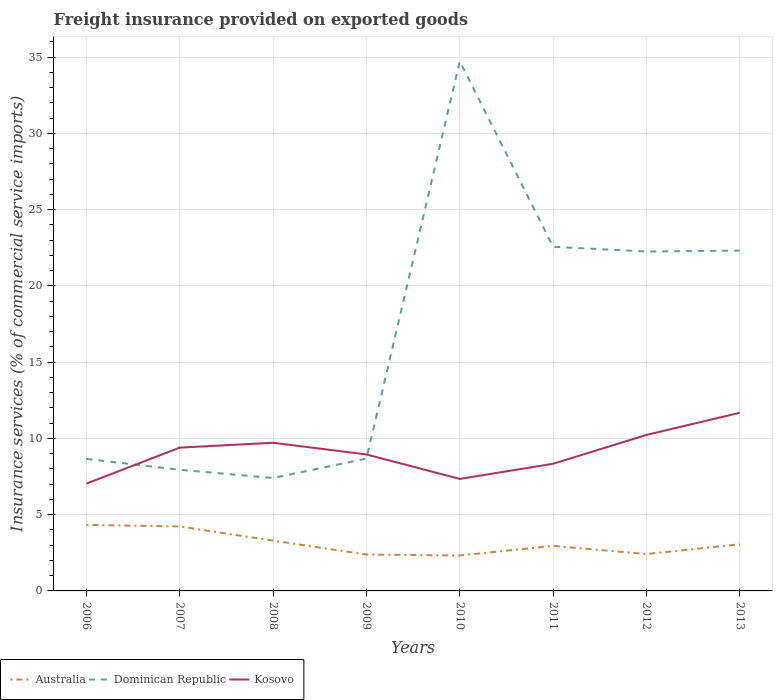How many different coloured lines are there?
Your response must be concise. 3. Does the line corresponding to Australia intersect with the line corresponding to Kosovo?
Give a very brief answer. No. Is the number of lines equal to the number of legend labels?
Give a very brief answer. Yes. Across all years, what is the maximum freight insurance provided on exported goods in Kosovo?
Your answer should be very brief. 7.04. In which year was the freight insurance provided on exported goods in Australia maximum?
Keep it short and to the point. 2010. What is the total freight insurance provided on exported goods in Kosovo in the graph?
Your response must be concise. -2.73. What is the difference between the highest and the second highest freight insurance provided on exported goods in Kosovo?
Keep it short and to the point. 4.64. Is the freight insurance provided on exported goods in Kosovo strictly greater than the freight insurance provided on exported goods in Australia over the years?
Ensure brevity in your answer.  No. How many years are there in the graph?
Your answer should be very brief. 8. Does the graph contain grids?
Offer a very short reply. Yes. Where does the legend appear in the graph?
Provide a succinct answer. Bottom left. How many legend labels are there?
Provide a succinct answer. 3. How are the legend labels stacked?
Your response must be concise. Horizontal. What is the title of the graph?
Your response must be concise. Freight insurance provided on exported goods. What is the label or title of the X-axis?
Ensure brevity in your answer.  Years. What is the label or title of the Y-axis?
Your response must be concise. Insurance services (% of commercial service imports). What is the Insurance services (% of commercial service imports) of Australia in 2006?
Your answer should be very brief. 4.33. What is the Insurance services (% of commercial service imports) in Dominican Republic in 2006?
Your response must be concise. 8.65. What is the Insurance services (% of commercial service imports) in Kosovo in 2006?
Give a very brief answer. 7.04. What is the Insurance services (% of commercial service imports) in Australia in 2007?
Make the answer very short. 4.23. What is the Insurance services (% of commercial service imports) of Dominican Republic in 2007?
Offer a very short reply. 7.94. What is the Insurance services (% of commercial service imports) of Kosovo in 2007?
Keep it short and to the point. 9.4. What is the Insurance services (% of commercial service imports) of Australia in 2008?
Your answer should be very brief. 3.3. What is the Insurance services (% of commercial service imports) in Dominican Republic in 2008?
Your response must be concise. 7.4. What is the Insurance services (% of commercial service imports) of Kosovo in 2008?
Offer a very short reply. 9.71. What is the Insurance services (% of commercial service imports) of Australia in 2009?
Offer a very short reply. 2.39. What is the Insurance services (% of commercial service imports) in Dominican Republic in 2009?
Offer a very short reply. 8.68. What is the Insurance services (% of commercial service imports) in Kosovo in 2009?
Give a very brief answer. 8.95. What is the Insurance services (% of commercial service imports) of Australia in 2010?
Give a very brief answer. 2.32. What is the Insurance services (% of commercial service imports) of Dominican Republic in 2010?
Your response must be concise. 34.73. What is the Insurance services (% of commercial service imports) of Kosovo in 2010?
Give a very brief answer. 7.34. What is the Insurance services (% of commercial service imports) of Australia in 2011?
Give a very brief answer. 2.95. What is the Insurance services (% of commercial service imports) in Dominican Republic in 2011?
Offer a very short reply. 22.56. What is the Insurance services (% of commercial service imports) of Kosovo in 2011?
Provide a short and direct response. 8.34. What is the Insurance services (% of commercial service imports) of Australia in 2012?
Give a very brief answer. 2.42. What is the Insurance services (% of commercial service imports) in Dominican Republic in 2012?
Your answer should be very brief. 22.25. What is the Insurance services (% of commercial service imports) of Kosovo in 2012?
Make the answer very short. 10.23. What is the Insurance services (% of commercial service imports) of Australia in 2013?
Offer a very short reply. 3.06. What is the Insurance services (% of commercial service imports) in Dominican Republic in 2013?
Your response must be concise. 22.31. What is the Insurance services (% of commercial service imports) of Kosovo in 2013?
Ensure brevity in your answer.  11.68. Across all years, what is the maximum Insurance services (% of commercial service imports) in Australia?
Make the answer very short. 4.33. Across all years, what is the maximum Insurance services (% of commercial service imports) of Dominican Republic?
Your answer should be compact. 34.73. Across all years, what is the maximum Insurance services (% of commercial service imports) in Kosovo?
Give a very brief answer. 11.68. Across all years, what is the minimum Insurance services (% of commercial service imports) in Australia?
Your answer should be very brief. 2.32. Across all years, what is the minimum Insurance services (% of commercial service imports) of Dominican Republic?
Give a very brief answer. 7.4. Across all years, what is the minimum Insurance services (% of commercial service imports) of Kosovo?
Give a very brief answer. 7.04. What is the total Insurance services (% of commercial service imports) of Australia in the graph?
Your response must be concise. 24.99. What is the total Insurance services (% of commercial service imports) of Dominican Republic in the graph?
Offer a very short reply. 134.54. What is the total Insurance services (% of commercial service imports) in Kosovo in the graph?
Your response must be concise. 72.69. What is the difference between the Insurance services (% of commercial service imports) in Australia in 2006 and that in 2007?
Your answer should be very brief. 0.1. What is the difference between the Insurance services (% of commercial service imports) in Dominican Republic in 2006 and that in 2007?
Offer a very short reply. 0.71. What is the difference between the Insurance services (% of commercial service imports) of Kosovo in 2006 and that in 2007?
Make the answer very short. -2.36. What is the difference between the Insurance services (% of commercial service imports) in Australia in 2006 and that in 2008?
Ensure brevity in your answer.  1.03. What is the difference between the Insurance services (% of commercial service imports) of Dominican Republic in 2006 and that in 2008?
Offer a very short reply. 1.25. What is the difference between the Insurance services (% of commercial service imports) of Kosovo in 2006 and that in 2008?
Make the answer very short. -2.68. What is the difference between the Insurance services (% of commercial service imports) of Australia in 2006 and that in 2009?
Ensure brevity in your answer.  1.94. What is the difference between the Insurance services (% of commercial service imports) of Dominican Republic in 2006 and that in 2009?
Provide a short and direct response. -0.03. What is the difference between the Insurance services (% of commercial service imports) in Kosovo in 2006 and that in 2009?
Offer a terse response. -1.91. What is the difference between the Insurance services (% of commercial service imports) of Australia in 2006 and that in 2010?
Offer a terse response. 2.01. What is the difference between the Insurance services (% of commercial service imports) of Dominican Republic in 2006 and that in 2010?
Your response must be concise. -26.07. What is the difference between the Insurance services (% of commercial service imports) of Kosovo in 2006 and that in 2010?
Provide a succinct answer. -0.31. What is the difference between the Insurance services (% of commercial service imports) of Australia in 2006 and that in 2011?
Offer a very short reply. 1.38. What is the difference between the Insurance services (% of commercial service imports) of Dominican Republic in 2006 and that in 2011?
Make the answer very short. -13.91. What is the difference between the Insurance services (% of commercial service imports) in Kosovo in 2006 and that in 2011?
Your answer should be very brief. -1.3. What is the difference between the Insurance services (% of commercial service imports) in Australia in 2006 and that in 2012?
Your answer should be very brief. 1.91. What is the difference between the Insurance services (% of commercial service imports) in Dominican Republic in 2006 and that in 2012?
Give a very brief answer. -13.6. What is the difference between the Insurance services (% of commercial service imports) of Kosovo in 2006 and that in 2012?
Your answer should be compact. -3.19. What is the difference between the Insurance services (% of commercial service imports) of Australia in 2006 and that in 2013?
Offer a terse response. 1.27. What is the difference between the Insurance services (% of commercial service imports) of Dominican Republic in 2006 and that in 2013?
Your answer should be compact. -13.66. What is the difference between the Insurance services (% of commercial service imports) in Kosovo in 2006 and that in 2013?
Keep it short and to the point. -4.64. What is the difference between the Insurance services (% of commercial service imports) in Australia in 2007 and that in 2008?
Offer a very short reply. 0.93. What is the difference between the Insurance services (% of commercial service imports) of Dominican Republic in 2007 and that in 2008?
Keep it short and to the point. 0.54. What is the difference between the Insurance services (% of commercial service imports) of Kosovo in 2007 and that in 2008?
Your answer should be very brief. -0.32. What is the difference between the Insurance services (% of commercial service imports) of Australia in 2007 and that in 2009?
Your response must be concise. 1.84. What is the difference between the Insurance services (% of commercial service imports) in Dominican Republic in 2007 and that in 2009?
Offer a very short reply. -0.74. What is the difference between the Insurance services (% of commercial service imports) in Kosovo in 2007 and that in 2009?
Make the answer very short. 0.45. What is the difference between the Insurance services (% of commercial service imports) of Australia in 2007 and that in 2010?
Offer a terse response. 1.9. What is the difference between the Insurance services (% of commercial service imports) of Dominican Republic in 2007 and that in 2010?
Keep it short and to the point. -26.79. What is the difference between the Insurance services (% of commercial service imports) in Kosovo in 2007 and that in 2010?
Ensure brevity in your answer.  2.05. What is the difference between the Insurance services (% of commercial service imports) in Australia in 2007 and that in 2011?
Your answer should be compact. 1.27. What is the difference between the Insurance services (% of commercial service imports) in Dominican Republic in 2007 and that in 2011?
Give a very brief answer. -14.62. What is the difference between the Insurance services (% of commercial service imports) in Kosovo in 2007 and that in 2011?
Provide a short and direct response. 1.06. What is the difference between the Insurance services (% of commercial service imports) of Australia in 2007 and that in 2012?
Keep it short and to the point. 1.81. What is the difference between the Insurance services (% of commercial service imports) in Dominican Republic in 2007 and that in 2012?
Offer a terse response. -14.31. What is the difference between the Insurance services (% of commercial service imports) of Kosovo in 2007 and that in 2012?
Ensure brevity in your answer.  -0.83. What is the difference between the Insurance services (% of commercial service imports) in Australia in 2007 and that in 2013?
Give a very brief answer. 1.17. What is the difference between the Insurance services (% of commercial service imports) of Dominican Republic in 2007 and that in 2013?
Provide a short and direct response. -14.37. What is the difference between the Insurance services (% of commercial service imports) in Kosovo in 2007 and that in 2013?
Give a very brief answer. -2.29. What is the difference between the Insurance services (% of commercial service imports) of Australia in 2008 and that in 2009?
Provide a short and direct response. 0.91. What is the difference between the Insurance services (% of commercial service imports) of Dominican Republic in 2008 and that in 2009?
Provide a succinct answer. -1.27. What is the difference between the Insurance services (% of commercial service imports) of Kosovo in 2008 and that in 2009?
Offer a terse response. 0.77. What is the difference between the Insurance services (% of commercial service imports) in Australia in 2008 and that in 2010?
Make the answer very short. 0.97. What is the difference between the Insurance services (% of commercial service imports) in Dominican Republic in 2008 and that in 2010?
Provide a short and direct response. -27.32. What is the difference between the Insurance services (% of commercial service imports) of Kosovo in 2008 and that in 2010?
Provide a short and direct response. 2.37. What is the difference between the Insurance services (% of commercial service imports) of Australia in 2008 and that in 2011?
Your answer should be very brief. 0.34. What is the difference between the Insurance services (% of commercial service imports) in Dominican Republic in 2008 and that in 2011?
Give a very brief answer. -15.16. What is the difference between the Insurance services (% of commercial service imports) in Kosovo in 2008 and that in 2011?
Your answer should be compact. 1.38. What is the difference between the Insurance services (% of commercial service imports) in Australia in 2008 and that in 2012?
Keep it short and to the point. 0.88. What is the difference between the Insurance services (% of commercial service imports) of Dominican Republic in 2008 and that in 2012?
Your answer should be compact. -14.85. What is the difference between the Insurance services (% of commercial service imports) of Kosovo in 2008 and that in 2012?
Keep it short and to the point. -0.51. What is the difference between the Insurance services (% of commercial service imports) of Australia in 2008 and that in 2013?
Offer a very short reply. 0.24. What is the difference between the Insurance services (% of commercial service imports) in Dominican Republic in 2008 and that in 2013?
Provide a short and direct response. -14.91. What is the difference between the Insurance services (% of commercial service imports) in Kosovo in 2008 and that in 2013?
Offer a very short reply. -1.97. What is the difference between the Insurance services (% of commercial service imports) of Australia in 2009 and that in 2010?
Make the answer very short. 0.06. What is the difference between the Insurance services (% of commercial service imports) in Dominican Republic in 2009 and that in 2010?
Your answer should be very brief. -26.05. What is the difference between the Insurance services (% of commercial service imports) of Kosovo in 2009 and that in 2010?
Make the answer very short. 1.6. What is the difference between the Insurance services (% of commercial service imports) of Australia in 2009 and that in 2011?
Ensure brevity in your answer.  -0.57. What is the difference between the Insurance services (% of commercial service imports) of Dominican Republic in 2009 and that in 2011?
Your response must be concise. -13.89. What is the difference between the Insurance services (% of commercial service imports) of Kosovo in 2009 and that in 2011?
Offer a very short reply. 0.61. What is the difference between the Insurance services (% of commercial service imports) of Australia in 2009 and that in 2012?
Keep it short and to the point. -0.03. What is the difference between the Insurance services (% of commercial service imports) in Dominican Republic in 2009 and that in 2012?
Your response must be concise. -13.57. What is the difference between the Insurance services (% of commercial service imports) in Kosovo in 2009 and that in 2012?
Keep it short and to the point. -1.28. What is the difference between the Insurance services (% of commercial service imports) in Australia in 2009 and that in 2013?
Offer a very short reply. -0.67. What is the difference between the Insurance services (% of commercial service imports) in Dominican Republic in 2009 and that in 2013?
Provide a short and direct response. -13.64. What is the difference between the Insurance services (% of commercial service imports) of Kosovo in 2009 and that in 2013?
Provide a succinct answer. -2.73. What is the difference between the Insurance services (% of commercial service imports) of Australia in 2010 and that in 2011?
Offer a terse response. -0.63. What is the difference between the Insurance services (% of commercial service imports) of Dominican Republic in 2010 and that in 2011?
Ensure brevity in your answer.  12.16. What is the difference between the Insurance services (% of commercial service imports) of Kosovo in 2010 and that in 2011?
Make the answer very short. -0.99. What is the difference between the Insurance services (% of commercial service imports) in Australia in 2010 and that in 2012?
Provide a short and direct response. -0.09. What is the difference between the Insurance services (% of commercial service imports) of Dominican Republic in 2010 and that in 2012?
Offer a very short reply. 12.47. What is the difference between the Insurance services (% of commercial service imports) in Kosovo in 2010 and that in 2012?
Offer a terse response. -2.89. What is the difference between the Insurance services (% of commercial service imports) of Australia in 2010 and that in 2013?
Make the answer very short. -0.74. What is the difference between the Insurance services (% of commercial service imports) of Dominican Republic in 2010 and that in 2013?
Your answer should be very brief. 12.41. What is the difference between the Insurance services (% of commercial service imports) in Kosovo in 2010 and that in 2013?
Ensure brevity in your answer.  -4.34. What is the difference between the Insurance services (% of commercial service imports) of Australia in 2011 and that in 2012?
Your answer should be very brief. 0.54. What is the difference between the Insurance services (% of commercial service imports) in Dominican Republic in 2011 and that in 2012?
Ensure brevity in your answer.  0.31. What is the difference between the Insurance services (% of commercial service imports) of Kosovo in 2011 and that in 2012?
Make the answer very short. -1.89. What is the difference between the Insurance services (% of commercial service imports) of Australia in 2011 and that in 2013?
Your answer should be very brief. -0.11. What is the difference between the Insurance services (% of commercial service imports) of Dominican Republic in 2011 and that in 2013?
Make the answer very short. 0.25. What is the difference between the Insurance services (% of commercial service imports) of Kosovo in 2011 and that in 2013?
Make the answer very short. -3.34. What is the difference between the Insurance services (% of commercial service imports) of Australia in 2012 and that in 2013?
Your answer should be compact. -0.64. What is the difference between the Insurance services (% of commercial service imports) in Dominican Republic in 2012 and that in 2013?
Give a very brief answer. -0.06. What is the difference between the Insurance services (% of commercial service imports) in Kosovo in 2012 and that in 2013?
Offer a terse response. -1.45. What is the difference between the Insurance services (% of commercial service imports) in Australia in 2006 and the Insurance services (% of commercial service imports) in Dominican Republic in 2007?
Keep it short and to the point. -3.61. What is the difference between the Insurance services (% of commercial service imports) of Australia in 2006 and the Insurance services (% of commercial service imports) of Kosovo in 2007?
Provide a short and direct response. -5.07. What is the difference between the Insurance services (% of commercial service imports) in Dominican Republic in 2006 and the Insurance services (% of commercial service imports) in Kosovo in 2007?
Give a very brief answer. -0.74. What is the difference between the Insurance services (% of commercial service imports) of Australia in 2006 and the Insurance services (% of commercial service imports) of Dominican Republic in 2008?
Make the answer very short. -3.08. What is the difference between the Insurance services (% of commercial service imports) in Australia in 2006 and the Insurance services (% of commercial service imports) in Kosovo in 2008?
Ensure brevity in your answer.  -5.38. What is the difference between the Insurance services (% of commercial service imports) in Dominican Republic in 2006 and the Insurance services (% of commercial service imports) in Kosovo in 2008?
Give a very brief answer. -1.06. What is the difference between the Insurance services (% of commercial service imports) of Australia in 2006 and the Insurance services (% of commercial service imports) of Dominican Republic in 2009?
Provide a succinct answer. -4.35. What is the difference between the Insurance services (% of commercial service imports) in Australia in 2006 and the Insurance services (% of commercial service imports) in Kosovo in 2009?
Your answer should be compact. -4.62. What is the difference between the Insurance services (% of commercial service imports) of Dominican Republic in 2006 and the Insurance services (% of commercial service imports) of Kosovo in 2009?
Your response must be concise. -0.29. What is the difference between the Insurance services (% of commercial service imports) of Australia in 2006 and the Insurance services (% of commercial service imports) of Dominican Republic in 2010?
Give a very brief answer. -30.4. What is the difference between the Insurance services (% of commercial service imports) in Australia in 2006 and the Insurance services (% of commercial service imports) in Kosovo in 2010?
Provide a succinct answer. -3.01. What is the difference between the Insurance services (% of commercial service imports) of Dominican Republic in 2006 and the Insurance services (% of commercial service imports) of Kosovo in 2010?
Offer a terse response. 1.31. What is the difference between the Insurance services (% of commercial service imports) of Australia in 2006 and the Insurance services (% of commercial service imports) of Dominican Republic in 2011?
Your answer should be very brief. -18.23. What is the difference between the Insurance services (% of commercial service imports) of Australia in 2006 and the Insurance services (% of commercial service imports) of Kosovo in 2011?
Provide a short and direct response. -4.01. What is the difference between the Insurance services (% of commercial service imports) in Dominican Republic in 2006 and the Insurance services (% of commercial service imports) in Kosovo in 2011?
Ensure brevity in your answer.  0.32. What is the difference between the Insurance services (% of commercial service imports) of Australia in 2006 and the Insurance services (% of commercial service imports) of Dominican Republic in 2012?
Offer a terse response. -17.92. What is the difference between the Insurance services (% of commercial service imports) of Australia in 2006 and the Insurance services (% of commercial service imports) of Kosovo in 2012?
Your answer should be compact. -5.9. What is the difference between the Insurance services (% of commercial service imports) of Dominican Republic in 2006 and the Insurance services (% of commercial service imports) of Kosovo in 2012?
Offer a terse response. -1.57. What is the difference between the Insurance services (% of commercial service imports) of Australia in 2006 and the Insurance services (% of commercial service imports) of Dominican Republic in 2013?
Your response must be concise. -17.98. What is the difference between the Insurance services (% of commercial service imports) of Australia in 2006 and the Insurance services (% of commercial service imports) of Kosovo in 2013?
Provide a short and direct response. -7.35. What is the difference between the Insurance services (% of commercial service imports) in Dominican Republic in 2006 and the Insurance services (% of commercial service imports) in Kosovo in 2013?
Your response must be concise. -3.03. What is the difference between the Insurance services (% of commercial service imports) in Australia in 2007 and the Insurance services (% of commercial service imports) in Dominican Republic in 2008?
Offer a terse response. -3.18. What is the difference between the Insurance services (% of commercial service imports) of Australia in 2007 and the Insurance services (% of commercial service imports) of Kosovo in 2008?
Provide a succinct answer. -5.49. What is the difference between the Insurance services (% of commercial service imports) of Dominican Republic in 2007 and the Insurance services (% of commercial service imports) of Kosovo in 2008?
Offer a terse response. -1.77. What is the difference between the Insurance services (% of commercial service imports) of Australia in 2007 and the Insurance services (% of commercial service imports) of Dominican Republic in 2009?
Offer a terse response. -4.45. What is the difference between the Insurance services (% of commercial service imports) of Australia in 2007 and the Insurance services (% of commercial service imports) of Kosovo in 2009?
Make the answer very short. -4.72. What is the difference between the Insurance services (% of commercial service imports) in Dominican Republic in 2007 and the Insurance services (% of commercial service imports) in Kosovo in 2009?
Keep it short and to the point. -1.01. What is the difference between the Insurance services (% of commercial service imports) in Australia in 2007 and the Insurance services (% of commercial service imports) in Dominican Republic in 2010?
Your answer should be compact. -30.5. What is the difference between the Insurance services (% of commercial service imports) in Australia in 2007 and the Insurance services (% of commercial service imports) in Kosovo in 2010?
Your response must be concise. -3.12. What is the difference between the Insurance services (% of commercial service imports) in Dominican Republic in 2007 and the Insurance services (% of commercial service imports) in Kosovo in 2010?
Offer a terse response. 0.6. What is the difference between the Insurance services (% of commercial service imports) in Australia in 2007 and the Insurance services (% of commercial service imports) in Dominican Republic in 2011?
Your response must be concise. -18.34. What is the difference between the Insurance services (% of commercial service imports) of Australia in 2007 and the Insurance services (% of commercial service imports) of Kosovo in 2011?
Provide a short and direct response. -4.11. What is the difference between the Insurance services (% of commercial service imports) in Dominican Republic in 2007 and the Insurance services (% of commercial service imports) in Kosovo in 2011?
Keep it short and to the point. -0.4. What is the difference between the Insurance services (% of commercial service imports) of Australia in 2007 and the Insurance services (% of commercial service imports) of Dominican Republic in 2012?
Make the answer very short. -18.03. What is the difference between the Insurance services (% of commercial service imports) in Australia in 2007 and the Insurance services (% of commercial service imports) in Kosovo in 2012?
Provide a short and direct response. -6. What is the difference between the Insurance services (% of commercial service imports) in Dominican Republic in 2007 and the Insurance services (% of commercial service imports) in Kosovo in 2012?
Your answer should be compact. -2.29. What is the difference between the Insurance services (% of commercial service imports) in Australia in 2007 and the Insurance services (% of commercial service imports) in Dominican Republic in 2013?
Your answer should be compact. -18.09. What is the difference between the Insurance services (% of commercial service imports) in Australia in 2007 and the Insurance services (% of commercial service imports) in Kosovo in 2013?
Your answer should be compact. -7.46. What is the difference between the Insurance services (% of commercial service imports) of Dominican Republic in 2007 and the Insurance services (% of commercial service imports) of Kosovo in 2013?
Your answer should be compact. -3.74. What is the difference between the Insurance services (% of commercial service imports) in Australia in 2008 and the Insurance services (% of commercial service imports) in Dominican Republic in 2009?
Give a very brief answer. -5.38. What is the difference between the Insurance services (% of commercial service imports) in Australia in 2008 and the Insurance services (% of commercial service imports) in Kosovo in 2009?
Offer a terse response. -5.65. What is the difference between the Insurance services (% of commercial service imports) in Dominican Republic in 2008 and the Insurance services (% of commercial service imports) in Kosovo in 2009?
Your answer should be compact. -1.54. What is the difference between the Insurance services (% of commercial service imports) of Australia in 2008 and the Insurance services (% of commercial service imports) of Dominican Republic in 2010?
Offer a very short reply. -31.43. What is the difference between the Insurance services (% of commercial service imports) of Australia in 2008 and the Insurance services (% of commercial service imports) of Kosovo in 2010?
Make the answer very short. -4.05. What is the difference between the Insurance services (% of commercial service imports) in Dominican Republic in 2008 and the Insurance services (% of commercial service imports) in Kosovo in 2010?
Make the answer very short. 0.06. What is the difference between the Insurance services (% of commercial service imports) of Australia in 2008 and the Insurance services (% of commercial service imports) of Dominican Republic in 2011?
Offer a very short reply. -19.27. What is the difference between the Insurance services (% of commercial service imports) in Australia in 2008 and the Insurance services (% of commercial service imports) in Kosovo in 2011?
Provide a short and direct response. -5.04. What is the difference between the Insurance services (% of commercial service imports) of Dominican Republic in 2008 and the Insurance services (% of commercial service imports) of Kosovo in 2011?
Provide a short and direct response. -0.93. What is the difference between the Insurance services (% of commercial service imports) in Australia in 2008 and the Insurance services (% of commercial service imports) in Dominican Republic in 2012?
Offer a very short reply. -18.96. What is the difference between the Insurance services (% of commercial service imports) in Australia in 2008 and the Insurance services (% of commercial service imports) in Kosovo in 2012?
Offer a terse response. -6.93. What is the difference between the Insurance services (% of commercial service imports) of Dominican Republic in 2008 and the Insurance services (% of commercial service imports) of Kosovo in 2012?
Provide a short and direct response. -2.82. What is the difference between the Insurance services (% of commercial service imports) in Australia in 2008 and the Insurance services (% of commercial service imports) in Dominican Republic in 2013?
Make the answer very short. -19.02. What is the difference between the Insurance services (% of commercial service imports) in Australia in 2008 and the Insurance services (% of commercial service imports) in Kosovo in 2013?
Make the answer very short. -8.38. What is the difference between the Insurance services (% of commercial service imports) of Dominican Republic in 2008 and the Insurance services (% of commercial service imports) of Kosovo in 2013?
Offer a very short reply. -4.28. What is the difference between the Insurance services (% of commercial service imports) in Australia in 2009 and the Insurance services (% of commercial service imports) in Dominican Republic in 2010?
Ensure brevity in your answer.  -32.34. What is the difference between the Insurance services (% of commercial service imports) in Australia in 2009 and the Insurance services (% of commercial service imports) in Kosovo in 2010?
Provide a short and direct response. -4.96. What is the difference between the Insurance services (% of commercial service imports) in Dominican Republic in 2009 and the Insurance services (% of commercial service imports) in Kosovo in 2010?
Your answer should be compact. 1.34. What is the difference between the Insurance services (% of commercial service imports) of Australia in 2009 and the Insurance services (% of commercial service imports) of Dominican Republic in 2011?
Provide a succinct answer. -20.18. What is the difference between the Insurance services (% of commercial service imports) in Australia in 2009 and the Insurance services (% of commercial service imports) in Kosovo in 2011?
Your response must be concise. -5.95. What is the difference between the Insurance services (% of commercial service imports) in Dominican Republic in 2009 and the Insurance services (% of commercial service imports) in Kosovo in 2011?
Your answer should be compact. 0.34. What is the difference between the Insurance services (% of commercial service imports) of Australia in 2009 and the Insurance services (% of commercial service imports) of Dominican Republic in 2012?
Offer a terse response. -19.87. What is the difference between the Insurance services (% of commercial service imports) in Australia in 2009 and the Insurance services (% of commercial service imports) in Kosovo in 2012?
Give a very brief answer. -7.84. What is the difference between the Insurance services (% of commercial service imports) in Dominican Republic in 2009 and the Insurance services (% of commercial service imports) in Kosovo in 2012?
Your answer should be compact. -1.55. What is the difference between the Insurance services (% of commercial service imports) of Australia in 2009 and the Insurance services (% of commercial service imports) of Dominican Republic in 2013?
Make the answer very short. -19.93. What is the difference between the Insurance services (% of commercial service imports) in Australia in 2009 and the Insurance services (% of commercial service imports) in Kosovo in 2013?
Your response must be concise. -9.3. What is the difference between the Insurance services (% of commercial service imports) in Dominican Republic in 2009 and the Insurance services (% of commercial service imports) in Kosovo in 2013?
Offer a terse response. -3. What is the difference between the Insurance services (% of commercial service imports) of Australia in 2010 and the Insurance services (% of commercial service imports) of Dominican Republic in 2011?
Give a very brief answer. -20.24. What is the difference between the Insurance services (% of commercial service imports) in Australia in 2010 and the Insurance services (% of commercial service imports) in Kosovo in 2011?
Offer a very short reply. -6.02. What is the difference between the Insurance services (% of commercial service imports) of Dominican Republic in 2010 and the Insurance services (% of commercial service imports) of Kosovo in 2011?
Your answer should be very brief. 26.39. What is the difference between the Insurance services (% of commercial service imports) in Australia in 2010 and the Insurance services (% of commercial service imports) in Dominican Republic in 2012?
Give a very brief answer. -19.93. What is the difference between the Insurance services (% of commercial service imports) of Australia in 2010 and the Insurance services (% of commercial service imports) of Kosovo in 2012?
Your response must be concise. -7.91. What is the difference between the Insurance services (% of commercial service imports) of Dominican Republic in 2010 and the Insurance services (% of commercial service imports) of Kosovo in 2012?
Your answer should be very brief. 24.5. What is the difference between the Insurance services (% of commercial service imports) of Australia in 2010 and the Insurance services (% of commercial service imports) of Dominican Republic in 2013?
Provide a succinct answer. -19.99. What is the difference between the Insurance services (% of commercial service imports) in Australia in 2010 and the Insurance services (% of commercial service imports) in Kosovo in 2013?
Keep it short and to the point. -9.36. What is the difference between the Insurance services (% of commercial service imports) in Dominican Republic in 2010 and the Insurance services (% of commercial service imports) in Kosovo in 2013?
Provide a succinct answer. 23.05. What is the difference between the Insurance services (% of commercial service imports) of Australia in 2011 and the Insurance services (% of commercial service imports) of Dominican Republic in 2012?
Provide a succinct answer. -19.3. What is the difference between the Insurance services (% of commercial service imports) in Australia in 2011 and the Insurance services (% of commercial service imports) in Kosovo in 2012?
Offer a terse response. -7.27. What is the difference between the Insurance services (% of commercial service imports) in Dominican Republic in 2011 and the Insurance services (% of commercial service imports) in Kosovo in 2012?
Offer a terse response. 12.34. What is the difference between the Insurance services (% of commercial service imports) in Australia in 2011 and the Insurance services (% of commercial service imports) in Dominican Republic in 2013?
Give a very brief answer. -19.36. What is the difference between the Insurance services (% of commercial service imports) in Australia in 2011 and the Insurance services (% of commercial service imports) in Kosovo in 2013?
Your answer should be very brief. -8.73. What is the difference between the Insurance services (% of commercial service imports) of Dominican Republic in 2011 and the Insurance services (% of commercial service imports) of Kosovo in 2013?
Give a very brief answer. 10.88. What is the difference between the Insurance services (% of commercial service imports) in Australia in 2012 and the Insurance services (% of commercial service imports) in Dominican Republic in 2013?
Give a very brief answer. -19.9. What is the difference between the Insurance services (% of commercial service imports) in Australia in 2012 and the Insurance services (% of commercial service imports) in Kosovo in 2013?
Your answer should be compact. -9.26. What is the difference between the Insurance services (% of commercial service imports) of Dominican Republic in 2012 and the Insurance services (% of commercial service imports) of Kosovo in 2013?
Your response must be concise. 10.57. What is the average Insurance services (% of commercial service imports) of Australia per year?
Keep it short and to the point. 3.12. What is the average Insurance services (% of commercial service imports) of Dominican Republic per year?
Provide a short and direct response. 16.82. What is the average Insurance services (% of commercial service imports) of Kosovo per year?
Provide a succinct answer. 9.09. In the year 2006, what is the difference between the Insurance services (% of commercial service imports) of Australia and Insurance services (% of commercial service imports) of Dominican Republic?
Keep it short and to the point. -4.32. In the year 2006, what is the difference between the Insurance services (% of commercial service imports) in Australia and Insurance services (% of commercial service imports) in Kosovo?
Ensure brevity in your answer.  -2.71. In the year 2006, what is the difference between the Insurance services (% of commercial service imports) of Dominican Republic and Insurance services (% of commercial service imports) of Kosovo?
Give a very brief answer. 1.62. In the year 2007, what is the difference between the Insurance services (% of commercial service imports) of Australia and Insurance services (% of commercial service imports) of Dominican Republic?
Offer a very short reply. -3.71. In the year 2007, what is the difference between the Insurance services (% of commercial service imports) of Australia and Insurance services (% of commercial service imports) of Kosovo?
Ensure brevity in your answer.  -5.17. In the year 2007, what is the difference between the Insurance services (% of commercial service imports) in Dominican Republic and Insurance services (% of commercial service imports) in Kosovo?
Provide a short and direct response. -1.46. In the year 2008, what is the difference between the Insurance services (% of commercial service imports) of Australia and Insurance services (% of commercial service imports) of Dominican Republic?
Offer a terse response. -4.11. In the year 2008, what is the difference between the Insurance services (% of commercial service imports) of Australia and Insurance services (% of commercial service imports) of Kosovo?
Make the answer very short. -6.42. In the year 2008, what is the difference between the Insurance services (% of commercial service imports) of Dominican Republic and Insurance services (% of commercial service imports) of Kosovo?
Your answer should be compact. -2.31. In the year 2009, what is the difference between the Insurance services (% of commercial service imports) of Australia and Insurance services (% of commercial service imports) of Dominican Republic?
Ensure brevity in your answer.  -6.29. In the year 2009, what is the difference between the Insurance services (% of commercial service imports) of Australia and Insurance services (% of commercial service imports) of Kosovo?
Keep it short and to the point. -6.56. In the year 2009, what is the difference between the Insurance services (% of commercial service imports) in Dominican Republic and Insurance services (% of commercial service imports) in Kosovo?
Your answer should be very brief. -0.27. In the year 2010, what is the difference between the Insurance services (% of commercial service imports) in Australia and Insurance services (% of commercial service imports) in Dominican Republic?
Make the answer very short. -32.4. In the year 2010, what is the difference between the Insurance services (% of commercial service imports) of Australia and Insurance services (% of commercial service imports) of Kosovo?
Ensure brevity in your answer.  -5.02. In the year 2010, what is the difference between the Insurance services (% of commercial service imports) in Dominican Republic and Insurance services (% of commercial service imports) in Kosovo?
Your answer should be compact. 27.38. In the year 2011, what is the difference between the Insurance services (% of commercial service imports) in Australia and Insurance services (% of commercial service imports) in Dominican Republic?
Offer a terse response. -19.61. In the year 2011, what is the difference between the Insurance services (% of commercial service imports) of Australia and Insurance services (% of commercial service imports) of Kosovo?
Your answer should be compact. -5.38. In the year 2011, what is the difference between the Insurance services (% of commercial service imports) of Dominican Republic and Insurance services (% of commercial service imports) of Kosovo?
Keep it short and to the point. 14.23. In the year 2012, what is the difference between the Insurance services (% of commercial service imports) of Australia and Insurance services (% of commercial service imports) of Dominican Republic?
Offer a terse response. -19.84. In the year 2012, what is the difference between the Insurance services (% of commercial service imports) in Australia and Insurance services (% of commercial service imports) in Kosovo?
Ensure brevity in your answer.  -7.81. In the year 2012, what is the difference between the Insurance services (% of commercial service imports) in Dominican Republic and Insurance services (% of commercial service imports) in Kosovo?
Provide a succinct answer. 12.02. In the year 2013, what is the difference between the Insurance services (% of commercial service imports) in Australia and Insurance services (% of commercial service imports) in Dominican Republic?
Provide a succinct answer. -19.25. In the year 2013, what is the difference between the Insurance services (% of commercial service imports) in Australia and Insurance services (% of commercial service imports) in Kosovo?
Offer a very short reply. -8.62. In the year 2013, what is the difference between the Insurance services (% of commercial service imports) in Dominican Republic and Insurance services (% of commercial service imports) in Kosovo?
Make the answer very short. 10.63. What is the ratio of the Insurance services (% of commercial service imports) in Australia in 2006 to that in 2007?
Offer a very short reply. 1.02. What is the ratio of the Insurance services (% of commercial service imports) in Dominican Republic in 2006 to that in 2007?
Your answer should be compact. 1.09. What is the ratio of the Insurance services (% of commercial service imports) of Kosovo in 2006 to that in 2007?
Your answer should be compact. 0.75. What is the ratio of the Insurance services (% of commercial service imports) of Australia in 2006 to that in 2008?
Your response must be concise. 1.31. What is the ratio of the Insurance services (% of commercial service imports) in Dominican Republic in 2006 to that in 2008?
Provide a short and direct response. 1.17. What is the ratio of the Insurance services (% of commercial service imports) of Kosovo in 2006 to that in 2008?
Your answer should be compact. 0.72. What is the ratio of the Insurance services (% of commercial service imports) of Australia in 2006 to that in 2009?
Offer a very short reply. 1.81. What is the ratio of the Insurance services (% of commercial service imports) of Kosovo in 2006 to that in 2009?
Your response must be concise. 0.79. What is the ratio of the Insurance services (% of commercial service imports) of Australia in 2006 to that in 2010?
Your response must be concise. 1.86. What is the ratio of the Insurance services (% of commercial service imports) of Dominican Republic in 2006 to that in 2010?
Keep it short and to the point. 0.25. What is the ratio of the Insurance services (% of commercial service imports) of Kosovo in 2006 to that in 2010?
Provide a succinct answer. 0.96. What is the ratio of the Insurance services (% of commercial service imports) of Australia in 2006 to that in 2011?
Offer a very short reply. 1.47. What is the ratio of the Insurance services (% of commercial service imports) of Dominican Republic in 2006 to that in 2011?
Your response must be concise. 0.38. What is the ratio of the Insurance services (% of commercial service imports) of Kosovo in 2006 to that in 2011?
Provide a succinct answer. 0.84. What is the ratio of the Insurance services (% of commercial service imports) of Australia in 2006 to that in 2012?
Your answer should be very brief. 1.79. What is the ratio of the Insurance services (% of commercial service imports) in Dominican Republic in 2006 to that in 2012?
Your response must be concise. 0.39. What is the ratio of the Insurance services (% of commercial service imports) of Kosovo in 2006 to that in 2012?
Offer a very short reply. 0.69. What is the ratio of the Insurance services (% of commercial service imports) of Australia in 2006 to that in 2013?
Give a very brief answer. 1.41. What is the ratio of the Insurance services (% of commercial service imports) of Dominican Republic in 2006 to that in 2013?
Your answer should be compact. 0.39. What is the ratio of the Insurance services (% of commercial service imports) of Kosovo in 2006 to that in 2013?
Give a very brief answer. 0.6. What is the ratio of the Insurance services (% of commercial service imports) in Australia in 2007 to that in 2008?
Your answer should be compact. 1.28. What is the ratio of the Insurance services (% of commercial service imports) in Dominican Republic in 2007 to that in 2008?
Provide a short and direct response. 1.07. What is the ratio of the Insurance services (% of commercial service imports) of Kosovo in 2007 to that in 2008?
Your answer should be very brief. 0.97. What is the ratio of the Insurance services (% of commercial service imports) of Australia in 2007 to that in 2009?
Your answer should be compact. 1.77. What is the ratio of the Insurance services (% of commercial service imports) of Dominican Republic in 2007 to that in 2009?
Provide a short and direct response. 0.91. What is the ratio of the Insurance services (% of commercial service imports) in Australia in 2007 to that in 2010?
Your answer should be compact. 1.82. What is the ratio of the Insurance services (% of commercial service imports) in Dominican Republic in 2007 to that in 2010?
Offer a terse response. 0.23. What is the ratio of the Insurance services (% of commercial service imports) of Kosovo in 2007 to that in 2010?
Provide a short and direct response. 1.28. What is the ratio of the Insurance services (% of commercial service imports) of Australia in 2007 to that in 2011?
Make the answer very short. 1.43. What is the ratio of the Insurance services (% of commercial service imports) in Dominican Republic in 2007 to that in 2011?
Provide a succinct answer. 0.35. What is the ratio of the Insurance services (% of commercial service imports) in Kosovo in 2007 to that in 2011?
Provide a short and direct response. 1.13. What is the ratio of the Insurance services (% of commercial service imports) in Australia in 2007 to that in 2012?
Your answer should be very brief. 1.75. What is the ratio of the Insurance services (% of commercial service imports) of Dominican Republic in 2007 to that in 2012?
Your answer should be very brief. 0.36. What is the ratio of the Insurance services (% of commercial service imports) in Kosovo in 2007 to that in 2012?
Offer a terse response. 0.92. What is the ratio of the Insurance services (% of commercial service imports) in Australia in 2007 to that in 2013?
Your answer should be compact. 1.38. What is the ratio of the Insurance services (% of commercial service imports) in Dominican Republic in 2007 to that in 2013?
Make the answer very short. 0.36. What is the ratio of the Insurance services (% of commercial service imports) in Kosovo in 2007 to that in 2013?
Ensure brevity in your answer.  0.8. What is the ratio of the Insurance services (% of commercial service imports) in Australia in 2008 to that in 2009?
Offer a terse response. 1.38. What is the ratio of the Insurance services (% of commercial service imports) in Dominican Republic in 2008 to that in 2009?
Keep it short and to the point. 0.85. What is the ratio of the Insurance services (% of commercial service imports) of Kosovo in 2008 to that in 2009?
Make the answer very short. 1.09. What is the ratio of the Insurance services (% of commercial service imports) of Australia in 2008 to that in 2010?
Offer a terse response. 1.42. What is the ratio of the Insurance services (% of commercial service imports) in Dominican Republic in 2008 to that in 2010?
Make the answer very short. 0.21. What is the ratio of the Insurance services (% of commercial service imports) of Kosovo in 2008 to that in 2010?
Make the answer very short. 1.32. What is the ratio of the Insurance services (% of commercial service imports) in Australia in 2008 to that in 2011?
Your answer should be compact. 1.12. What is the ratio of the Insurance services (% of commercial service imports) in Dominican Republic in 2008 to that in 2011?
Provide a succinct answer. 0.33. What is the ratio of the Insurance services (% of commercial service imports) in Kosovo in 2008 to that in 2011?
Provide a short and direct response. 1.17. What is the ratio of the Insurance services (% of commercial service imports) of Australia in 2008 to that in 2012?
Provide a short and direct response. 1.36. What is the ratio of the Insurance services (% of commercial service imports) in Dominican Republic in 2008 to that in 2012?
Keep it short and to the point. 0.33. What is the ratio of the Insurance services (% of commercial service imports) of Kosovo in 2008 to that in 2012?
Keep it short and to the point. 0.95. What is the ratio of the Insurance services (% of commercial service imports) of Australia in 2008 to that in 2013?
Your answer should be very brief. 1.08. What is the ratio of the Insurance services (% of commercial service imports) in Dominican Republic in 2008 to that in 2013?
Offer a terse response. 0.33. What is the ratio of the Insurance services (% of commercial service imports) of Kosovo in 2008 to that in 2013?
Offer a very short reply. 0.83. What is the ratio of the Insurance services (% of commercial service imports) of Dominican Republic in 2009 to that in 2010?
Your response must be concise. 0.25. What is the ratio of the Insurance services (% of commercial service imports) of Kosovo in 2009 to that in 2010?
Make the answer very short. 1.22. What is the ratio of the Insurance services (% of commercial service imports) in Australia in 2009 to that in 2011?
Your answer should be compact. 0.81. What is the ratio of the Insurance services (% of commercial service imports) of Dominican Republic in 2009 to that in 2011?
Your response must be concise. 0.38. What is the ratio of the Insurance services (% of commercial service imports) of Kosovo in 2009 to that in 2011?
Ensure brevity in your answer.  1.07. What is the ratio of the Insurance services (% of commercial service imports) of Australia in 2009 to that in 2012?
Your answer should be very brief. 0.99. What is the ratio of the Insurance services (% of commercial service imports) in Dominican Republic in 2009 to that in 2012?
Provide a short and direct response. 0.39. What is the ratio of the Insurance services (% of commercial service imports) of Kosovo in 2009 to that in 2012?
Your answer should be very brief. 0.87. What is the ratio of the Insurance services (% of commercial service imports) of Australia in 2009 to that in 2013?
Provide a short and direct response. 0.78. What is the ratio of the Insurance services (% of commercial service imports) of Dominican Republic in 2009 to that in 2013?
Ensure brevity in your answer.  0.39. What is the ratio of the Insurance services (% of commercial service imports) of Kosovo in 2009 to that in 2013?
Offer a terse response. 0.77. What is the ratio of the Insurance services (% of commercial service imports) in Australia in 2010 to that in 2011?
Ensure brevity in your answer.  0.79. What is the ratio of the Insurance services (% of commercial service imports) of Dominican Republic in 2010 to that in 2011?
Ensure brevity in your answer.  1.54. What is the ratio of the Insurance services (% of commercial service imports) of Kosovo in 2010 to that in 2011?
Provide a succinct answer. 0.88. What is the ratio of the Insurance services (% of commercial service imports) in Australia in 2010 to that in 2012?
Provide a short and direct response. 0.96. What is the ratio of the Insurance services (% of commercial service imports) in Dominican Republic in 2010 to that in 2012?
Ensure brevity in your answer.  1.56. What is the ratio of the Insurance services (% of commercial service imports) in Kosovo in 2010 to that in 2012?
Provide a short and direct response. 0.72. What is the ratio of the Insurance services (% of commercial service imports) in Australia in 2010 to that in 2013?
Offer a terse response. 0.76. What is the ratio of the Insurance services (% of commercial service imports) of Dominican Republic in 2010 to that in 2013?
Ensure brevity in your answer.  1.56. What is the ratio of the Insurance services (% of commercial service imports) of Kosovo in 2010 to that in 2013?
Keep it short and to the point. 0.63. What is the ratio of the Insurance services (% of commercial service imports) in Australia in 2011 to that in 2012?
Make the answer very short. 1.22. What is the ratio of the Insurance services (% of commercial service imports) of Kosovo in 2011 to that in 2012?
Ensure brevity in your answer.  0.82. What is the ratio of the Insurance services (% of commercial service imports) in Australia in 2011 to that in 2013?
Your answer should be very brief. 0.97. What is the ratio of the Insurance services (% of commercial service imports) in Dominican Republic in 2011 to that in 2013?
Provide a short and direct response. 1.01. What is the ratio of the Insurance services (% of commercial service imports) of Kosovo in 2011 to that in 2013?
Keep it short and to the point. 0.71. What is the ratio of the Insurance services (% of commercial service imports) of Australia in 2012 to that in 2013?
Offer a terse response. 0.79. What is the ratio of the Insurance services (% of commercial service imports) in Kosovo in 2012 to that in 2013?
Provide a short and direct response. 0.88. What is the difference between the highest and the second highest Insurance services (% of commercial service imports) of Australia?
Provide a succinct answer. 0.1. What is the difference between the highest and the second highest Insurance services (% of commercial service imports) in Dominican Republic?
Provide a short and direct response. 12.16. What is the difference between the highest and the second highest Insurance services (% of commercial service imports) in Kosovo?
Your answer should be very brief. 1.45. What is the difference between the highest and the lowest Insurance services (% of commercial service imports) in Australia?
Keep it short and to the point. 2.01. What is the difference between the highest and the lowest Insurance services (% of commercial service imports) of Dominican Republic?
Your response must be concise. 27.32. What is the difference between the highest and the lowest Insurance services (% of commercial service imports) in Kosovo?
Provide a short and direct response. 4.64. 